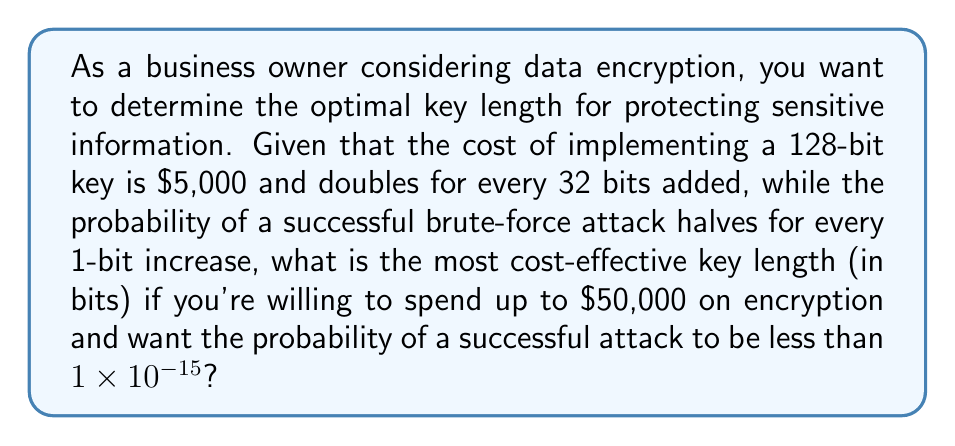Show me your answer to this math problem. Let's approach this step-by-step:

1) First, let's establish the relationship between key length and cost:
   128 bits: $5,000
   160 bits: $10,000
   192 bits: $20,000
   224 bits: $40,000

2) Now, let's consider the probability of a successful attack. If we start with a 128-bit key, we can calculate the probability for each key length:
   128 bits: $P_{128} = 2^{-128} \approx 2.94 \times 10^{-39}$
   160 bits: $P_{160} = P_{128} \times 2^{-32} \approx 6.85 \times 10^{-49}$
   192 bits: $P_{192} = P_{160} \times 2^{-32} \approx 1.59 \times 10^{-58}$
   224 bits: $P_{224} = P_{192} \times 2^{-32} \approx 3.70 \times 10^{-68}$

3) All of these probabilities are well below the required $1 \times 10^{-15}$, so we need to consider the cost constraint.

4) The highest cost within our budget is $40,000, which corresponds to a 224-bit key.

5) Therefore, the most cost-effective key length that meets both our security and budget requirements is 224 bits.
Answer: 224 bits 